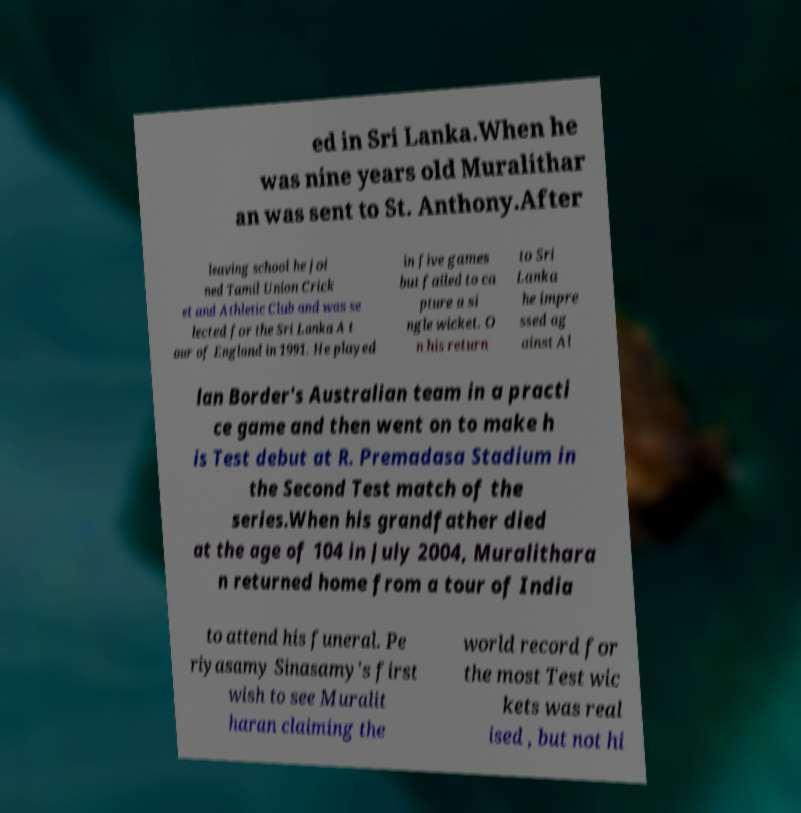What messages or text are displayed in this image? I need them in a readable, typed format. ed in Sri Lanka.When he was nine years old Muralithar an was sent to St. Anthony.After leaving school he joi ned Tamil Union Crick et and Athletic Club and was se lected for the Sri Lanka A t our of England in 1991. He played in five games but failed to ca pture a si ngle wicket. O n his return to Sri Lanka he impre ssed ag ainst Al lan Border's Australian team in a practi ce game and then went on to make h is Test debut at R. Premadasa Stadium in the Second Test match of the series.When his grandfather died at the age of 104 in July 2004, Muralithara n returned home from a tour of India to attend his funeral. Pe riyasamy Sinasamy's first wish to see Muralit haran claiming the world record for the most Test wic kets was real ised , but not hi 